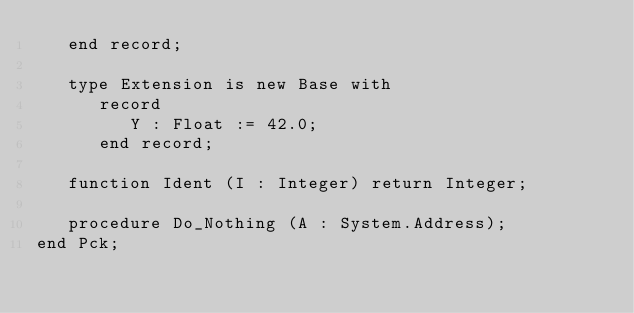<code> <loc_0><loc_0><loc_500><loc_500><_Ada_>   end record;

   type Extension is new Base with
      record
         Y : Float := 42.0;
      end record;

   function Ident (I : Integer) return Integer;

   procedure Do_Nothing (A : System.Address);
end Pck;
</code> 